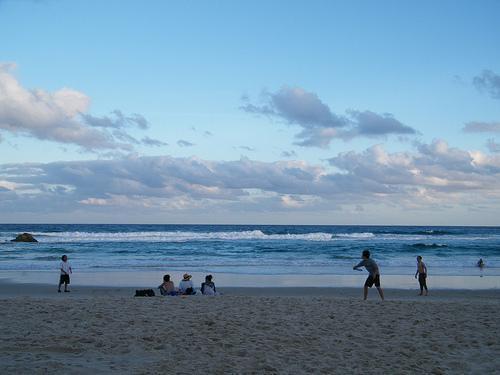How many of the frisbees can be seen?
Give a very brief answer. 1. 